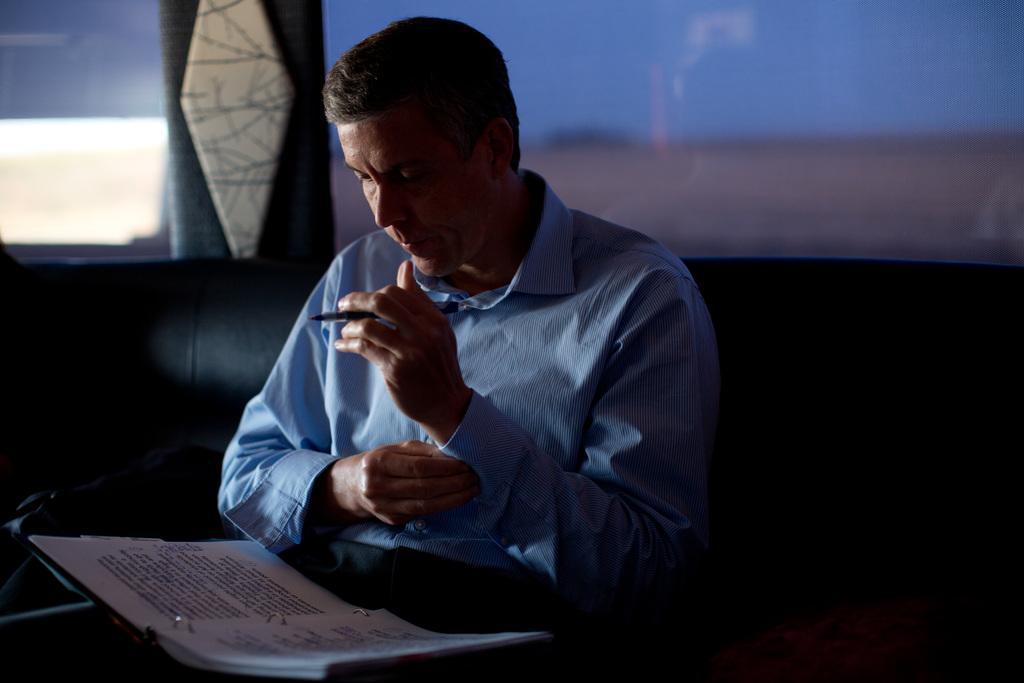How would you summarize this image in a sentence or two? In this picture I can see a person sitting on the couch and holding pen, he is watching into the book which is placed on his arms, behind we can see glass window to the wall. 